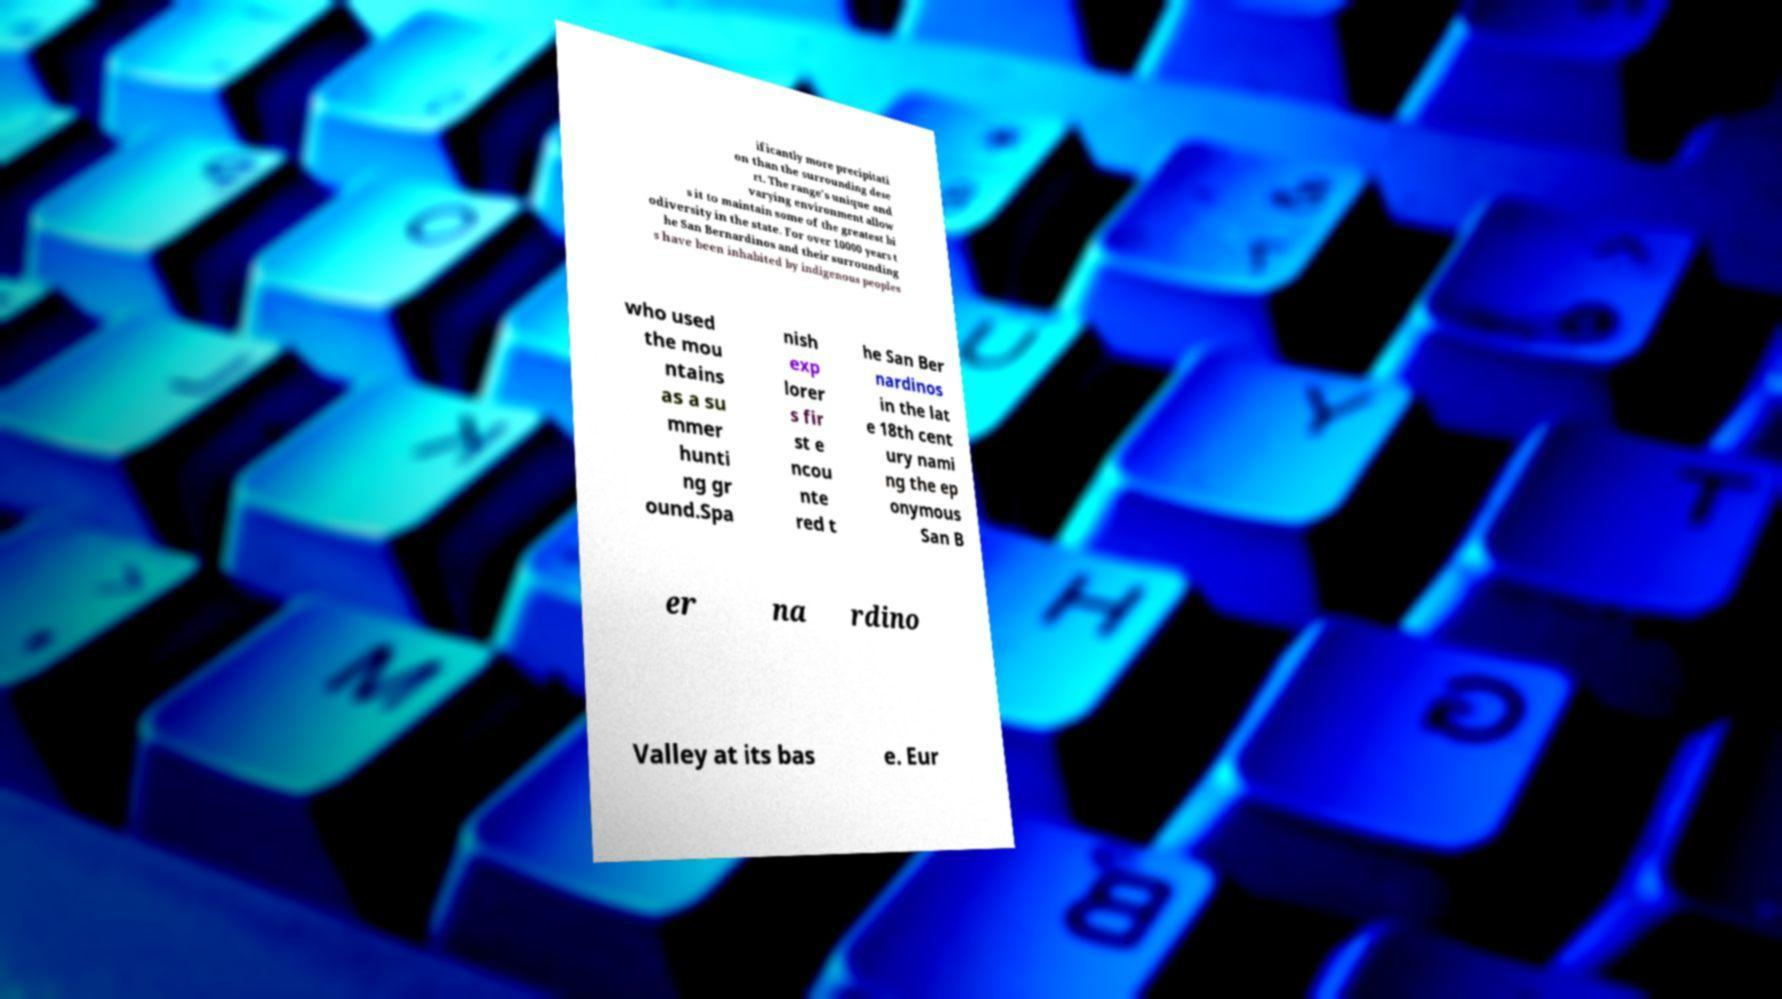Could you assist in decoding the text presented in this image and type it out clearly? ificantly more precipitati on than the surrounding dese rt. The range's unique and varying environment allow s it to maintain some of the greatest bi odiversity in the state. For over 10000 years t he San Bernardinos and their surrounding s have been inhabited by indigenous peoples who used the mou ntains as a su mmer hunti ng gr ound.Spa nish exp lorer s fir st e ncou nte red t he San Ber nardinos in the lat e 18th cent ury nami ng the ep onymous San B er na rdino Valley at its bas e. Eur 